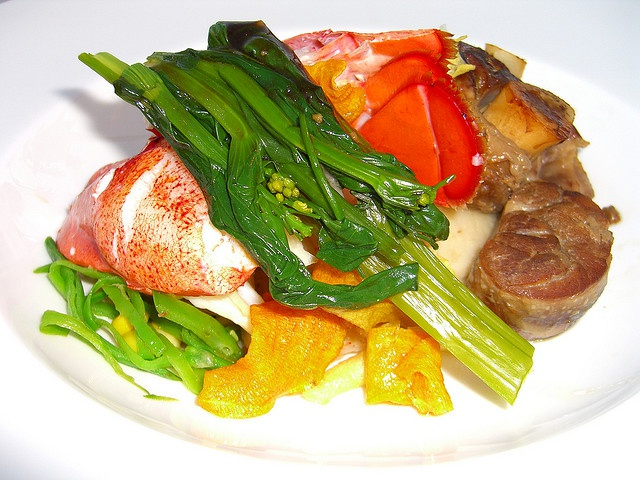Describe the objects in this image and their specific colors. I can see various objects in this image with different colors. 